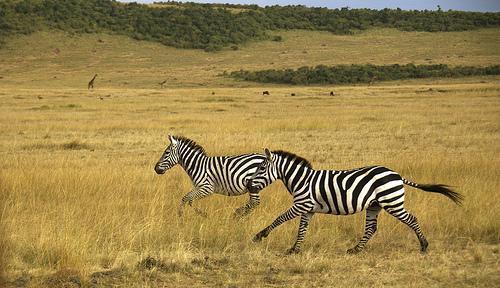How many zebras are there?
Give a very brief answer. 2. How many giraffes are in the photo?
Give a very brief answer. 1. How many zebras are shown?
Give a very brief answer. 2. 